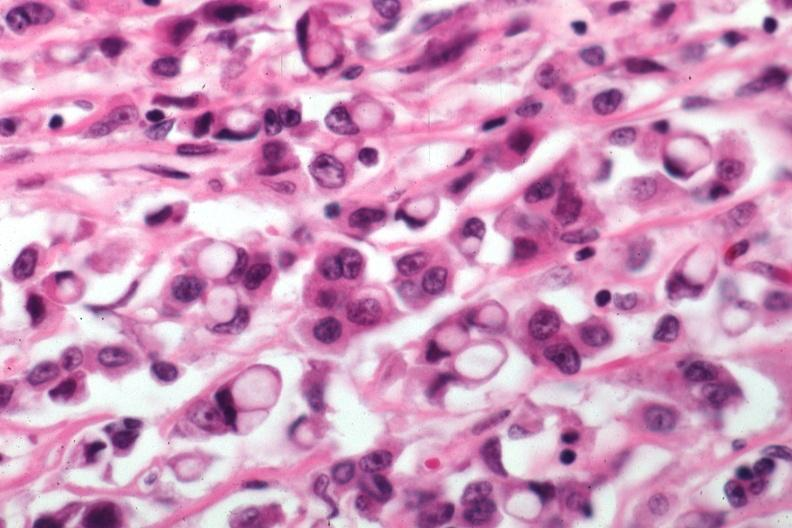where is this area in the body?
Answer the question using a single word or phrase. Breast 